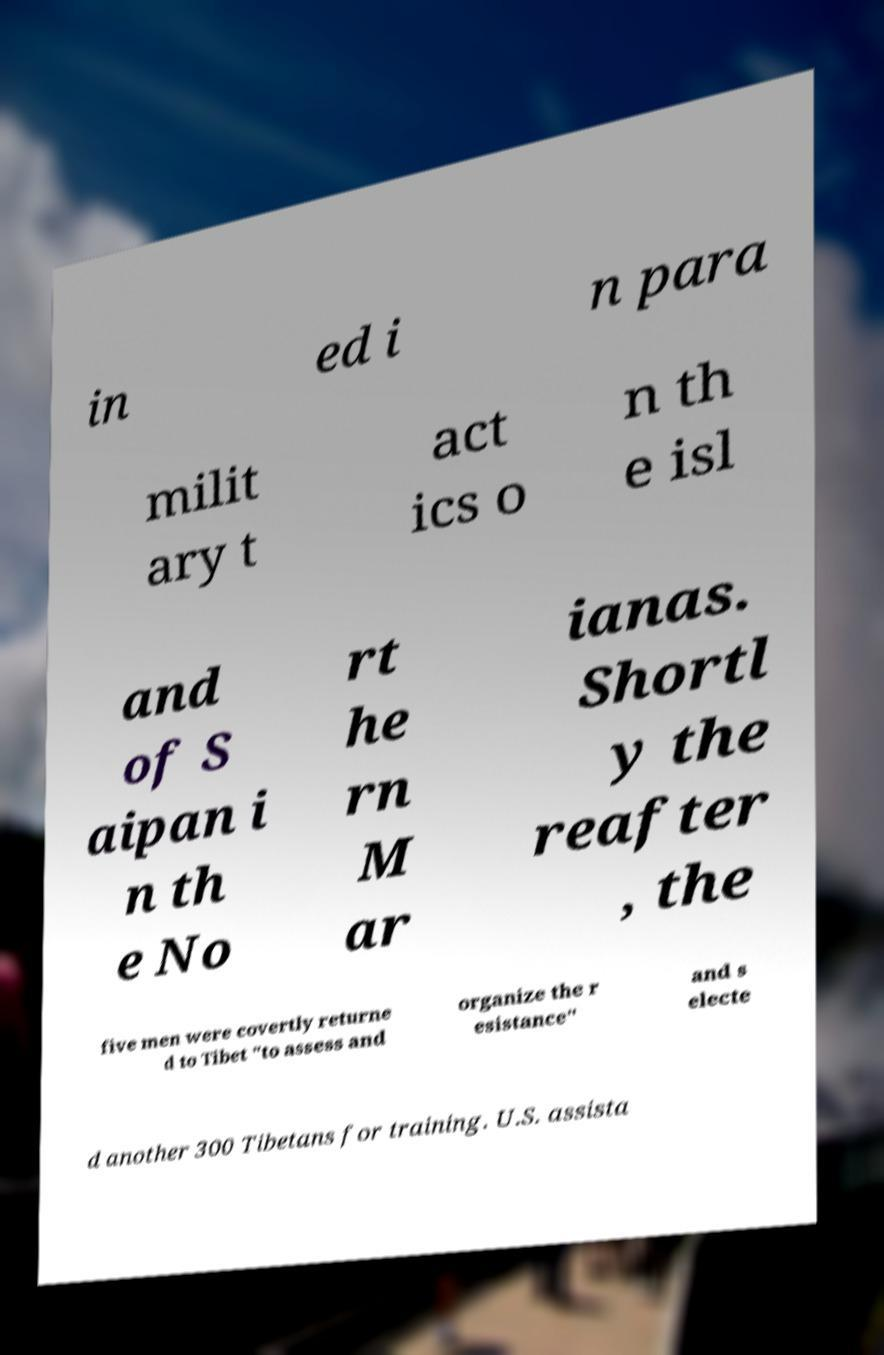There's text embedded in this image that I need extracted. Can you transcribe it verbatim? in ed i n para milit ary t act ics o n th e isl and of S aipan i n th e No rt he rn M ar ianas. Shortl y the reafter , the five men were covertly returne d to Tibet "to assess and organize the r esistance" and s electe d another 300 Tibetans for training. U.S. assista 